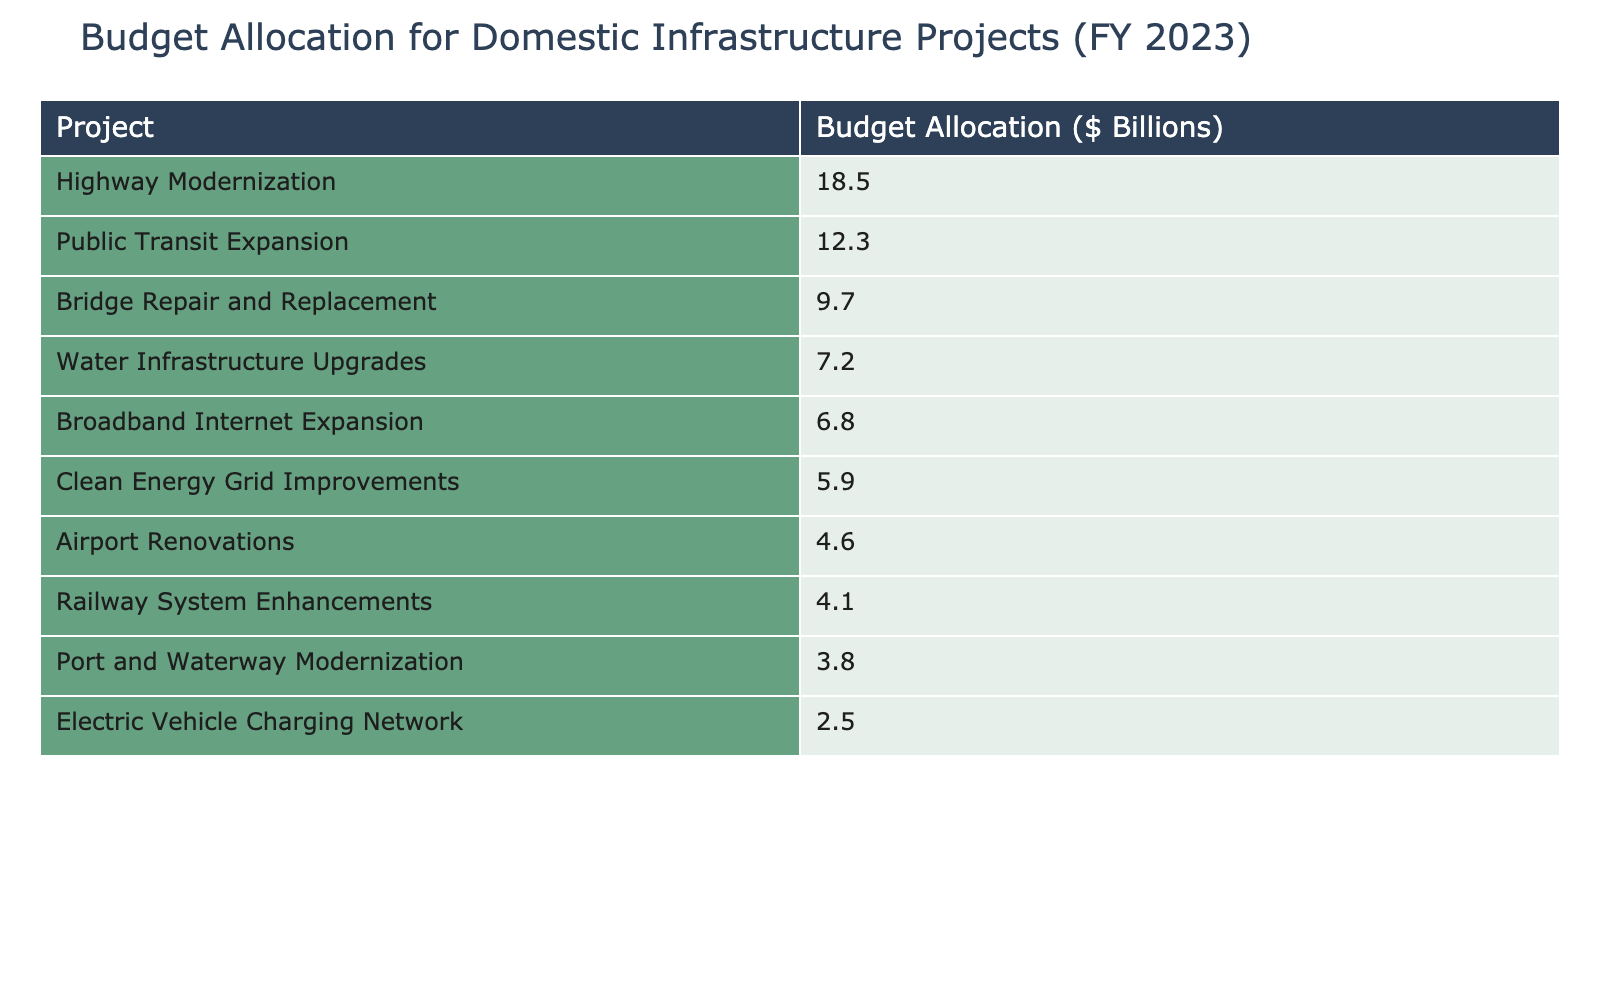What is the total budget allocation for all listed infrastructure projects? To find the total budget allocation, sum all the budget values: 18.5 + 12.3 + 9.7 + 7.2 + 6.8 + 5.9 + 4.6 + 4.1 + 3.8 + 2.5 = 75.4
Answer: 75.4 billion Which infrastructure project has the highest budget allocation? The project with the highest budget allocation is Highway Modernization at 18.5 billion.
Answer: Highway Modernization How much more funding is allocated for Public Transit Expansion than for Electric Vehicle Charging Network? To find the difference, subtract the budget of Electric Vehicle Charging Network from Public Transit Expansion: 12.3 - 2.5 = 9.8
Answer: 9.8 billion What percentage of the total budget does the Water Infrastructure Upgrades project represent? First, calculate the percentage: (7.2 / 75.4) * 100 ≈ 9.53%. Therefore, Water Infrastructure Upgrades represent about 9.53% of the total budget.
Answer: 9.53% Is the budget for Clean Energy Grid Improvements more than the combined budgets of Port and Waterway Modernization and Electric Vehicle Charging Network? First, add the budgets for Port and Waterway Modernization (3.8 billion) and Electric Vehicle Charging Network (2.5 billion), which totals 6.3 billion. Then compare this to Clean Energy Grid Improvements (5.9 billion). Since 5.9 is less than 6.3, the answer is no.
Answer: No What is the average budget allocation for the top three projects? The top three projects are Highway Modernization (18.5 billion), Public Transit Expansion (12.3 billion), and Bridge Repair and Replacement (9.7 billion). The sum is 18.5 + 12.3 + 9.7 = 40.5 billion. The average is 40.5 / 3 = 13.5 billion.
Answer: 13.5 billion Which project has the smallest budget allocation, and what is its value? The project with the smallest budget allocation is Electric Vehicle Charging Network, with a budget of 2.5 billion.
Answer: Electric Vehicle Charging Network, 2.5 billion If we combine the budgets of Highway Modernization and Bridge Repair and Replacement, how much do we get? Add together the budgets for these two projects: 18.5 + 9.7 = 28.2 billion.
Answer: 28.2 billion Is the combined budget for Broadband Internet Expansion and Clean Energy Grid Improvements more than that of Railway System Enhancements? First, combine the budgets of Broadband Internet Expansion (6.8 billion) and Clean Energy Grid Improvements (5.9 billion), which is 12.7 billion. Then compare this to Railway System Enhancements (4.1 billion). Since 12.7 billion is greater than 4.1 billion, the answer is yes.
Answer: Yes 